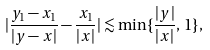<formula> <loc_0><loc_0><loc_500><loc_500>| \frac { y _ { 1 } - x _ { 1 } } { | y - x | } - \frac { x _ { 1 } } { | x | } | \lesssim \min \{ \frac { | y | } { | x | } , \, 1 \} ,</formula> 